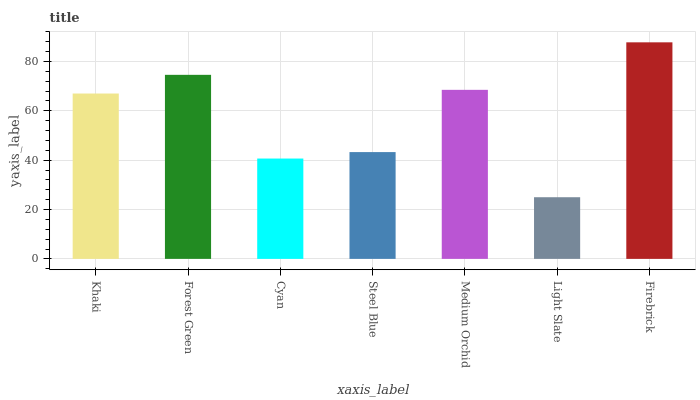Is Light Slate the minimum?
Answer yes or no. Yes. Is Firebrick the maximum?
Answer yes or no. Yes. Is Forest Green the minimum?
Answer yes or no. No. Is Forest Green the maximum?
Answer yes or no. No. Is Forest Green greater than Khaki?
Answer yes or no. Yes. Is Khaki less than Forest Green?
Answer yes or no. Yes. Is Khaki greater than Forest Green?
Answer yes or no. No. Is Forest Green less than Khaki?
Answer yes or no. No. Is Khaki the high median?
Answer yes or no. Yes. Is Khaki the low median?
Answer yes or no. Yes. Is Medium Orchid the high median?
Answer yes or no. No. Is Forest Green the low median?
Answer yes or no. No. 